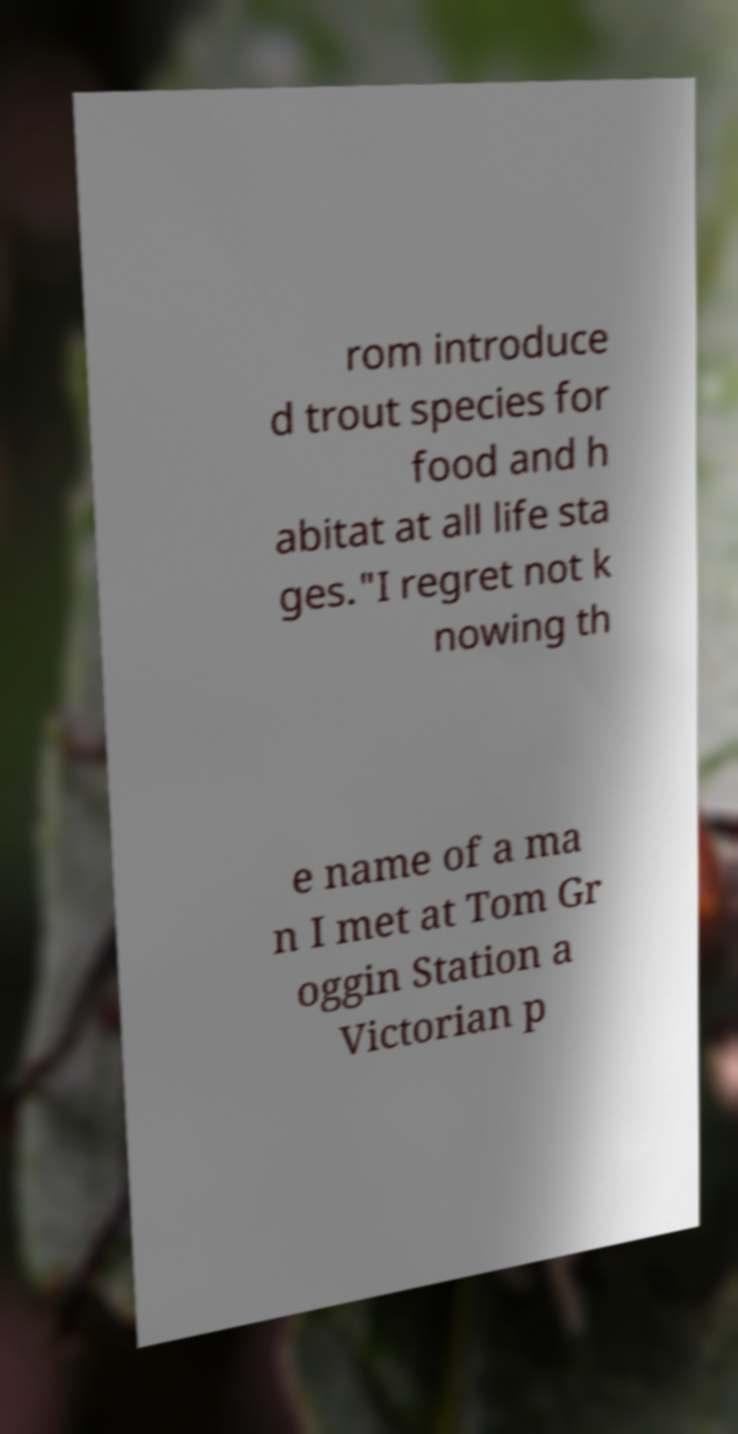Could you extract and type out the text from this image? rom introduce d trout species for food and h abitat at all life sta ges."I regret not k nowing th e name of a ma n I met at Tom Gr oggin Station a Victorian p 